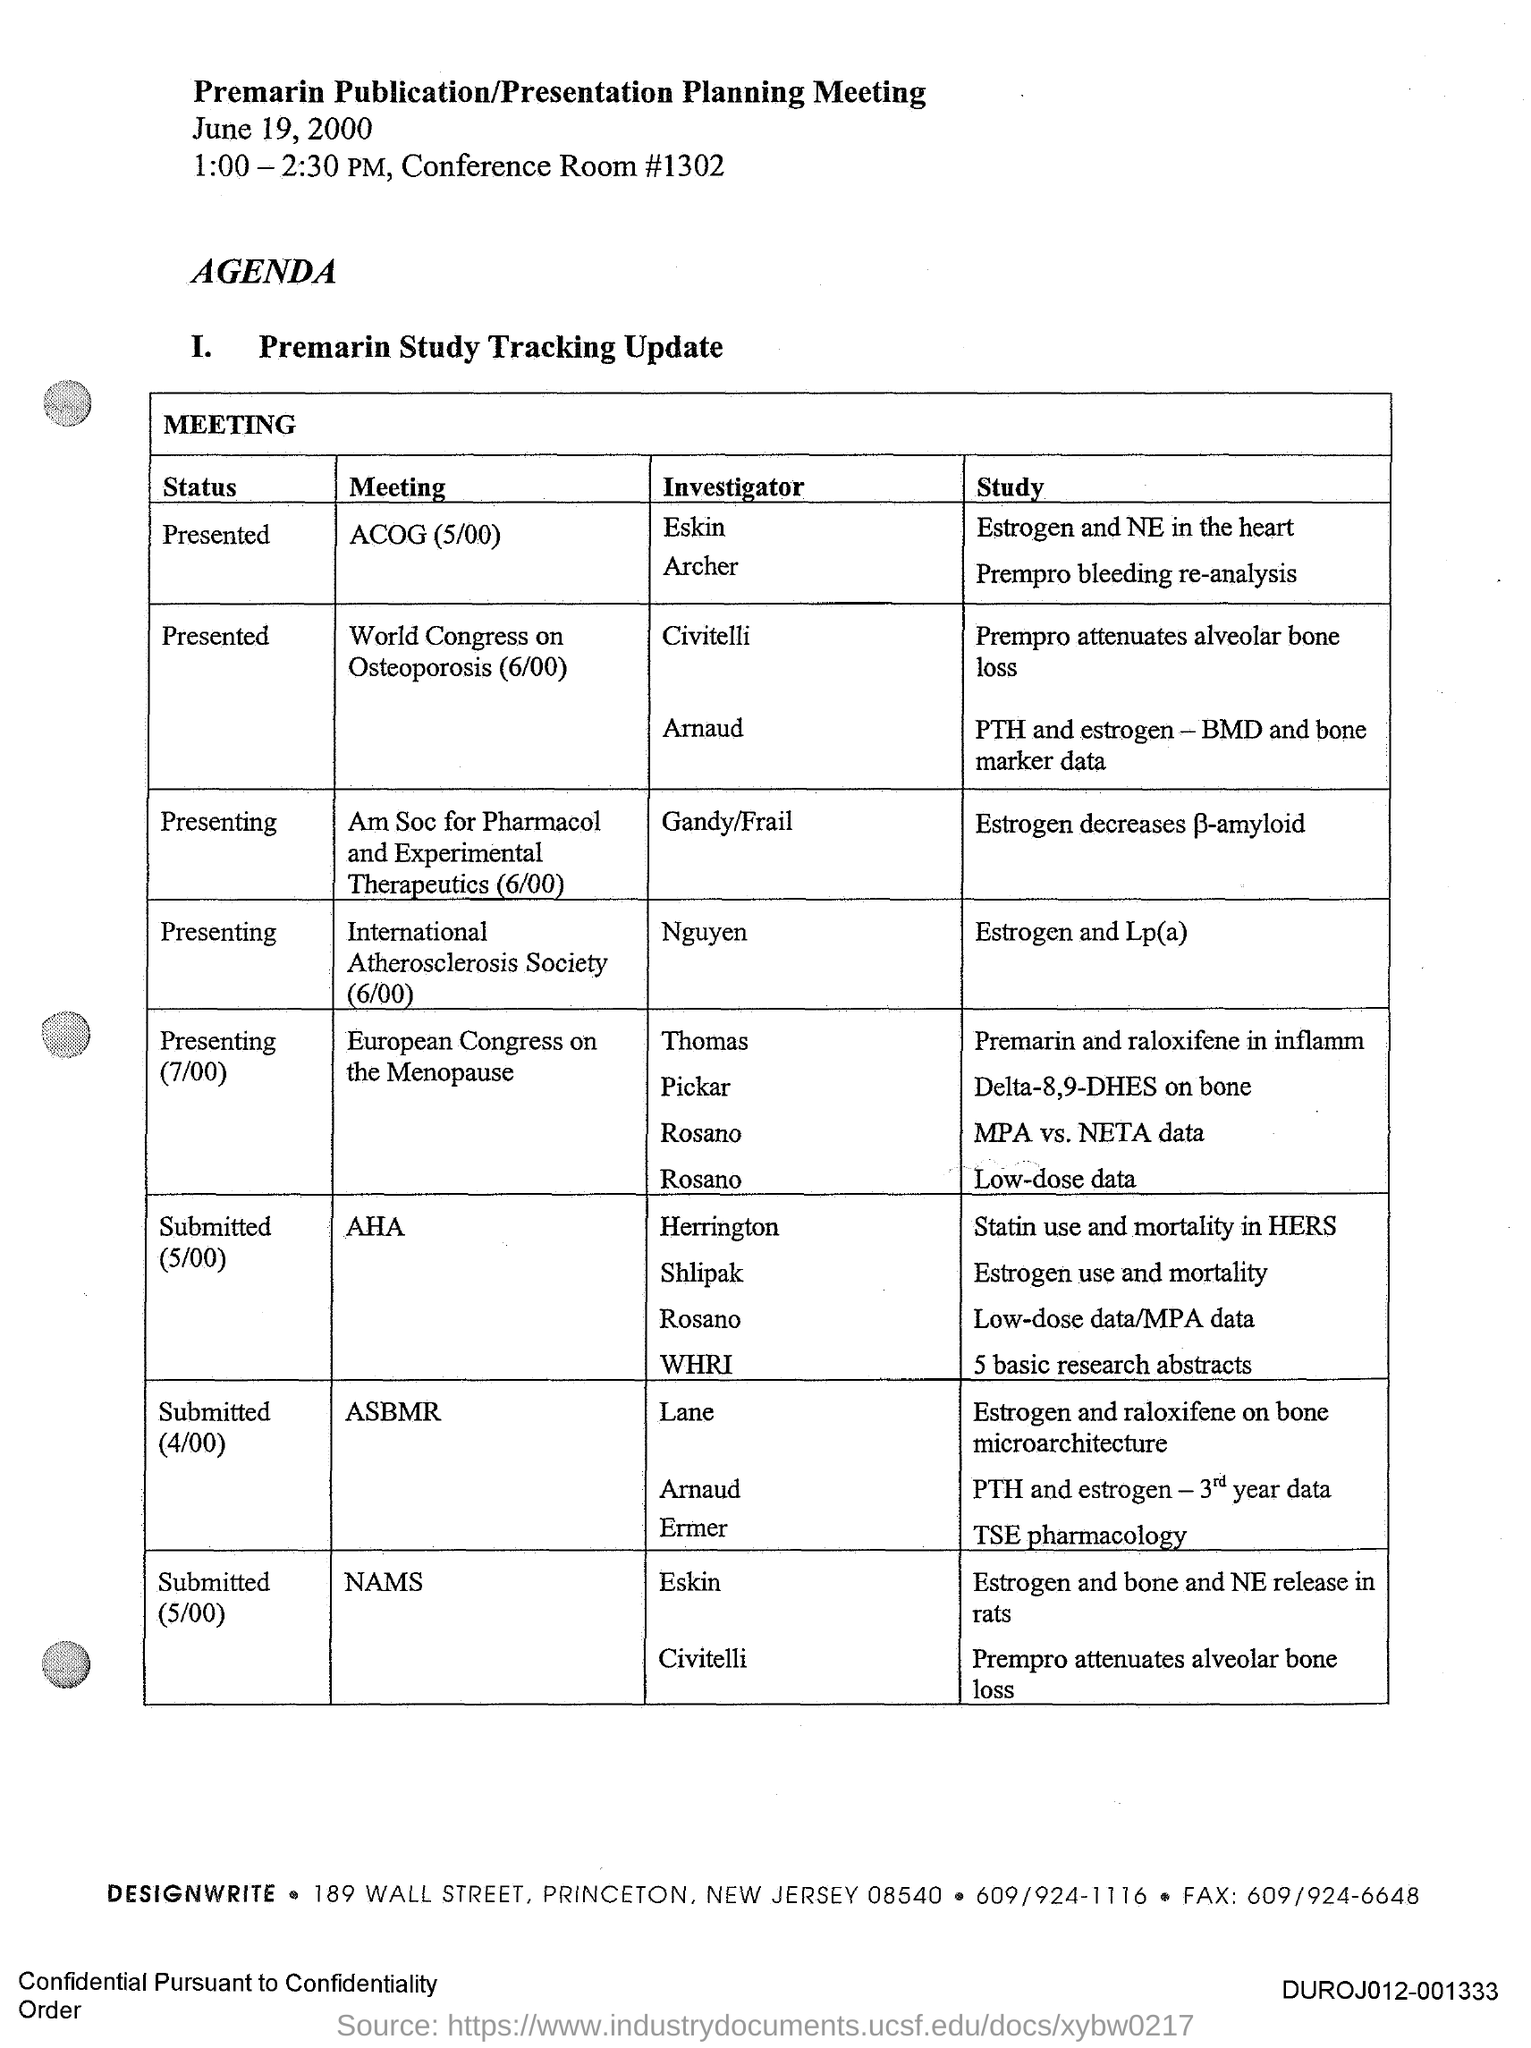What date is the Premarin Publication/Presentation Planning Meeting held?
Make the answer very short. June 19, 2000. What time is the Premarin Publication/Presentation Planning Meeting scheduled?
Offer a very short reply. 1:00 - 2:30 PM. Who is the investigator for the study 'Estrogen and Lp(a)'?
Offer a terse response. Nguyen. What is the status of the study 'Estrogen and Lp(a)'?
Give a very brief answer. Presenting. 